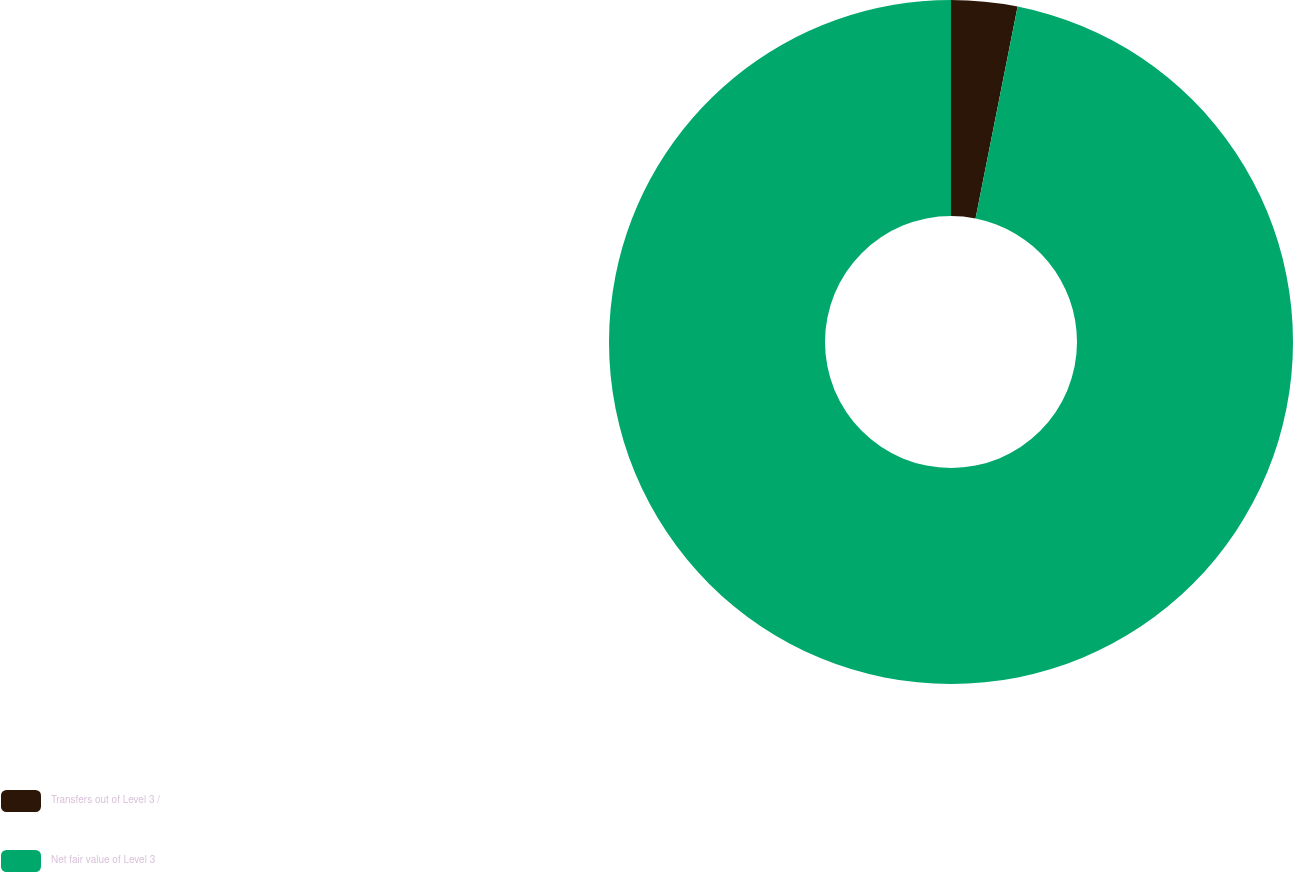Convert chart to OTSL. <chart><loc_0><loc_0><loc_500><loc_500><pie_chart><fcel>Transfers out of Level 3 /<fcel>Net fair value of Level 3<nl><fcel>3.12%<fcel>96.88%<nl></chart> 